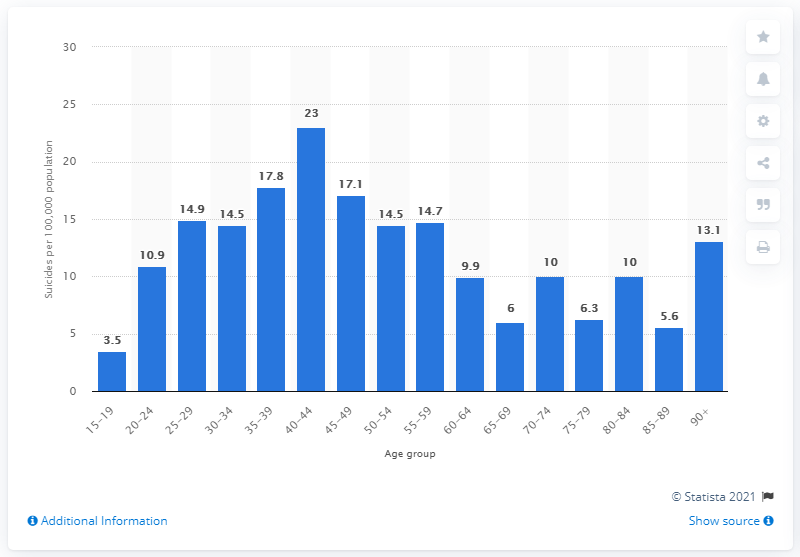Specify some key components in this picture. In the age groups 35 to 39 years, the rate of deaths per 100,000 people was 17.8. 